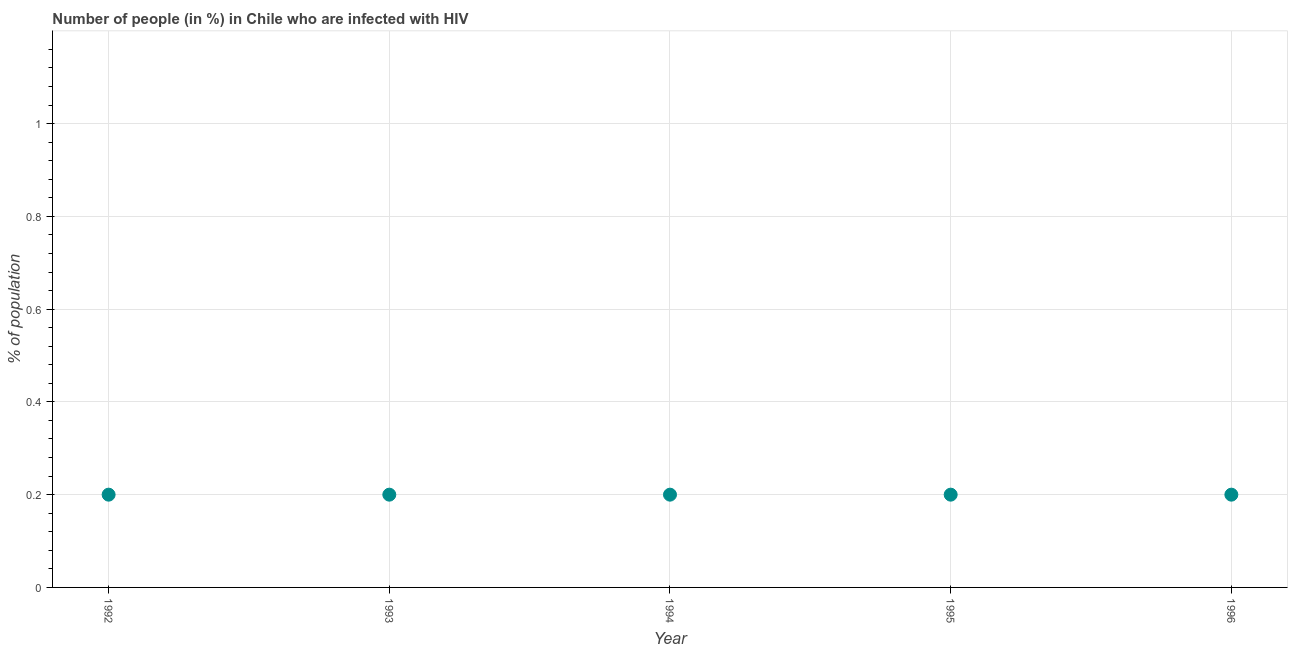What is the number of people infected with hiv in 1992?
Offer a very short reply. 0.2. Across all years, what is the maximum number of people infected with hiv?
Give a very brief answer. 0.2. In which year was the number of people infected with hiv maximum?
Give a very brief answer. 1992. In which year was the number of people infected with hiv minimum?
Your answer should be compact. 1992. What is the sum of the number of people infected with hiv?
Provide a succinct answer. 1. What is the difference between the number of people infected with hiv in 1992 and 1994?
Your response must be concise. 0. What is the average number of people infected with hiv per year?
Make the answer very short. 0.2. What is the median number of people infected with hiv?
Provide a short and direct response. 0.2. What is the ratio of the number of people infected with hiv in 1993 to that in 1994?
Ensure brevity in your answer.  1. What is the difference between the highest and the second highest number of people infected with hiv?
Ensure brevity in your answer.  0. In how many years, is the number of people infected with hiv greater than the average number of people infected with hiv taken over all years?
Give a very brief answer. 0. How many dotlines are there?
Ensure brevity in your answer.  1. What is the difference between two consecutive major ticks on the Y-axis?
Your answer should be compact. 0.2. Does the graph contain any zero values?
Provide a succinct answer. No. What is the title of the graph?
Make the answer very short. Number of people (in %) in Chile who are infected with HIV. What is the label or title of the Y-axis?
Give a very brief answer. % of population. What is the % of population in 1992?
Give a very brief answer. 0.2. What is the % of population in 1993?
Give a very brief answer. 0.2. What is the % of population in 1994?
Keep it short and to the point. 0.2. What is the % of population in 1996?
Provide a succinct answer. 0.2. What is the difference between the % of population in 1992 and 1993?
Ensure brevity in your answer.  0. What is the difference between the % of population in 1992 and 1994?
Give a very brief answer. 0. What is the difference between the % of population in 1992 and 1995?
Provide a short and direct response. 0. What is the difference between the % of population in 1992 and 1996?
Provide a short and direct response. 0. What is the difference between the % of population in 1993 and 1996?
Offer a very short reply. 0. What is the difference between the % of population in 1994 and 1996?
Provide a succinct answer. 0. What is the ratio of the % of population in 1992 to that in 1994?
Offer a very short reply. 1. What is the ratio of the % of population in 1992 to that in 1995?
Provide a succinct answer. 1. What is the ratio of the % of population in 1993 to that in 1995?
Provide a short and direct response. 1. What is the ratio of the % of population in 1993 to that in 1996?
Your answer should be compact. 1. 